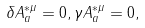<formula> <loc_0><loc_0><loc_500><loc_500>\delta A _ { a } ^ { * \mu } = 0 , \gamma A _ { a } ^ { * \mu } = 0 ,</formula> 